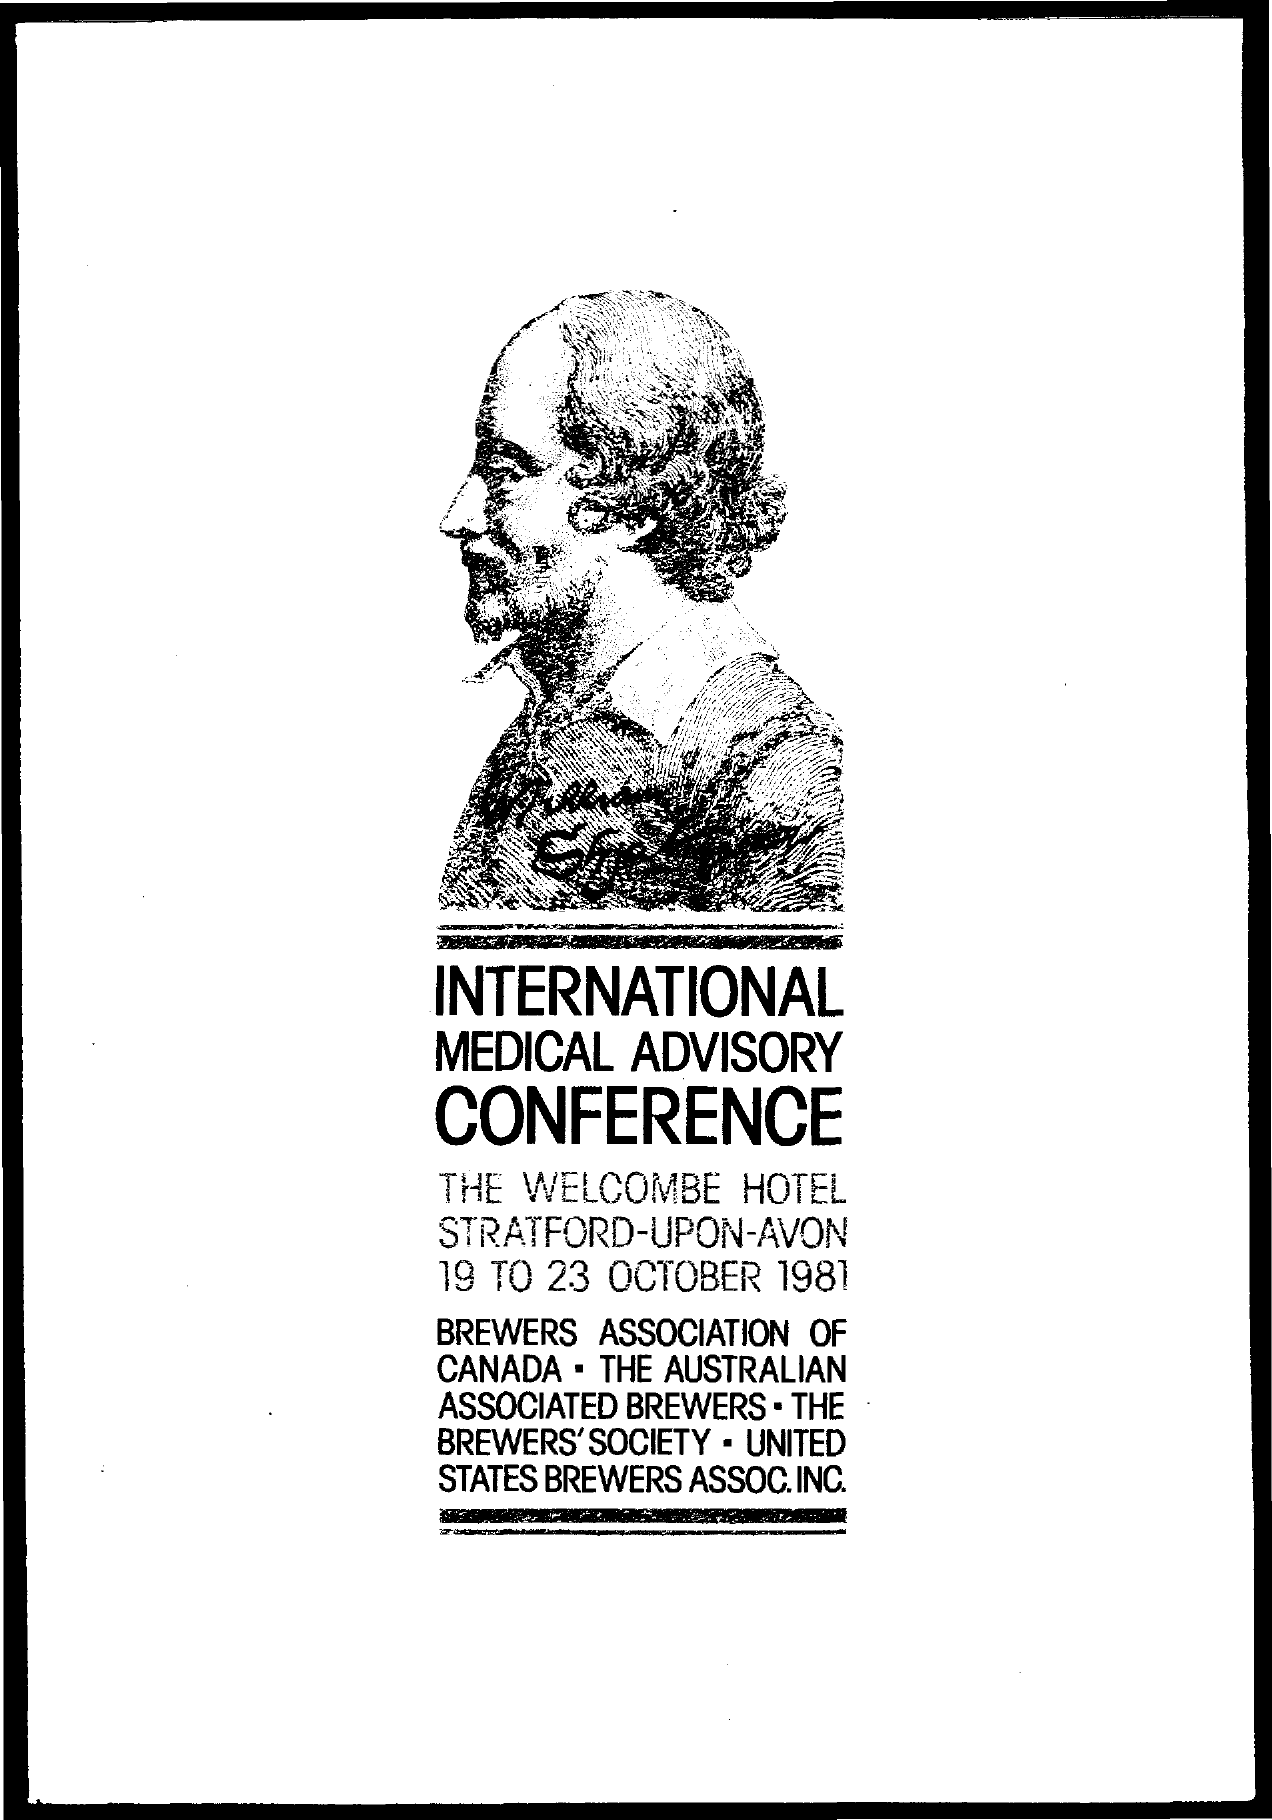When is the International Medical Advisory Conference held?
Your answer should be very brief. 19 to 23 October 1981. 